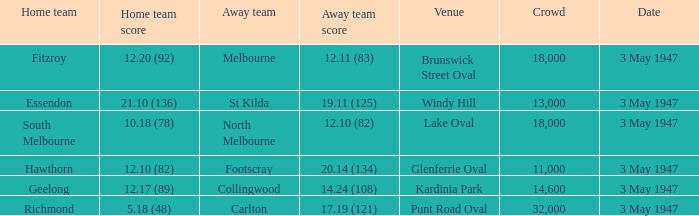In the game where the home team scored 12.17 (89), who was the home team? Geelong. 